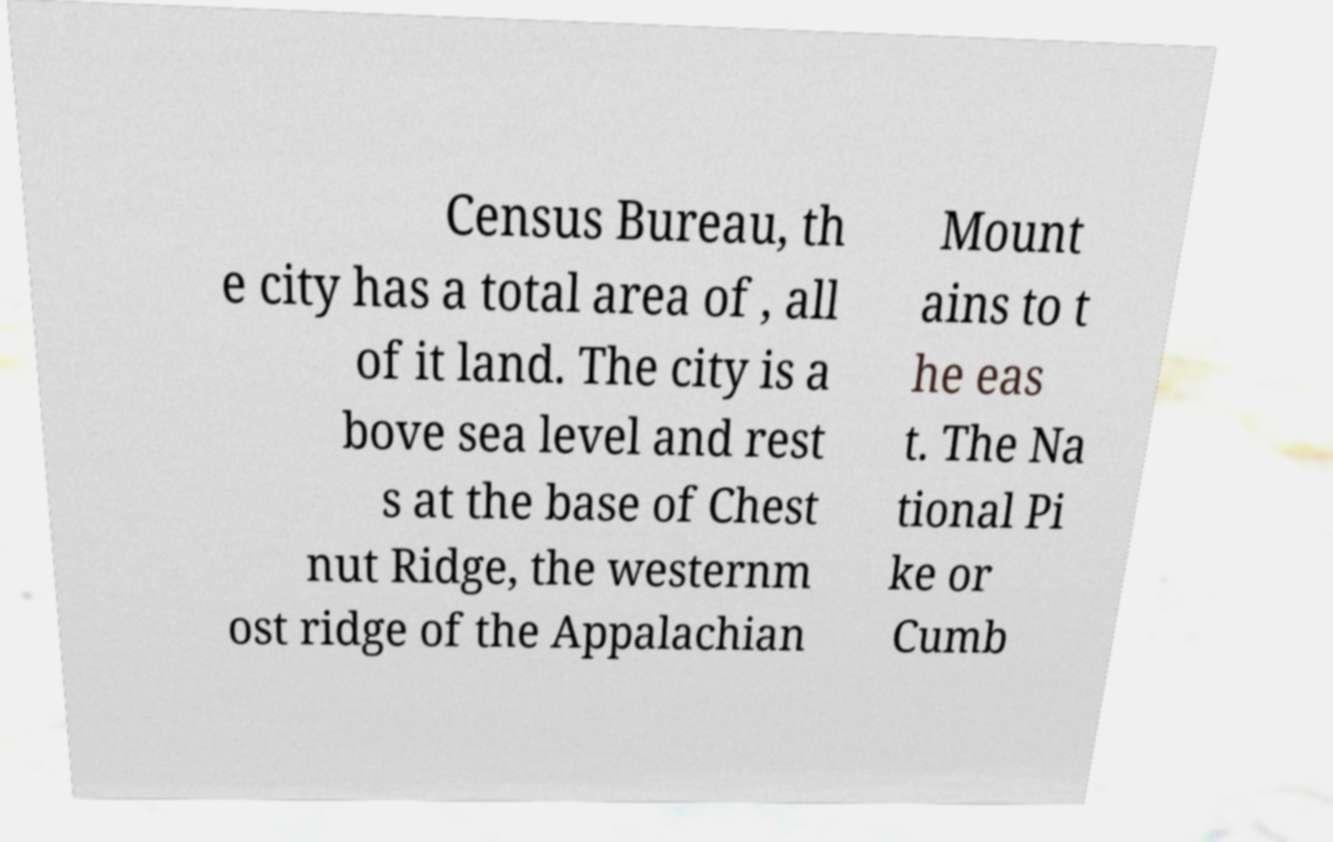There's text embedded in this image that I need extracted. Can you transcribe it verbatim? Census Bureau, th e city has a total area of , all of it land. The city is a bove sea level and rest s at the base of Chest nut Ridge, the westernm ost ridge of the Appalachian Mount ains to t he eas t. The Na tional Pi ke or Cumb 